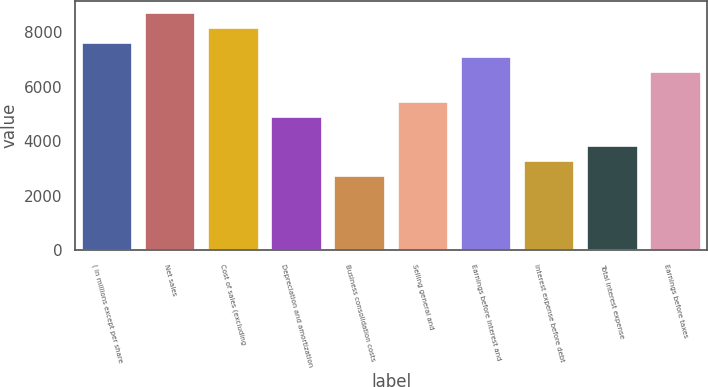Convert chart to OTSL. <chart><loc_0><loc_0><loc_500><loc_500><bar_chart><fcel>( in millions except per share<fcel>Net sales<fcel>Cost of sales (excluding<fcel>Depreciation and amortization<fcel>Business consolidation costs<fcel>Selling general and<fcel>Earnings before interest and<fcel>Interest expense before debt<fcel>Total interest expense<fcel>Earnings before taxes<nl><fcel>7616.14<fcel>8704.1<fcel>8160.12<fcel>4896.24<fcel>2720.29<fcel>5440.22<fcel>7072.16<fcel>3264.28<fcel>3808.27<fcel>6528.18<nl></chart> 